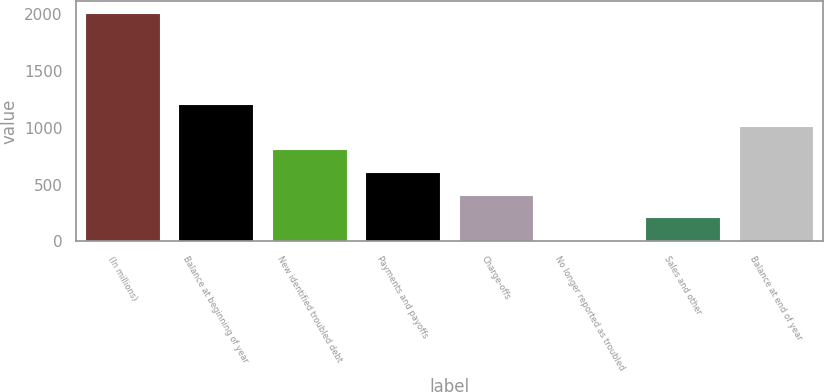Convert chart to OTSL. <chart><loc_0><loc_0><loc_500><loc_500><bar_chart><fcel>(In millions)<fcel>Balance at beginning of year<fcel>New identified troubled debt<fcel>Payments and payoffs<fcel>Charge-offs<fcel>No longer reported as troubled<fcel>Sales and other<fcel>Balance at end of year<nl><fcel>2016<fcel>1213.6<fcel>812.4<fcel>611.8<fcel>411.2<fcel>10<fcel>210.6<fcel>1013<nl></chart> 